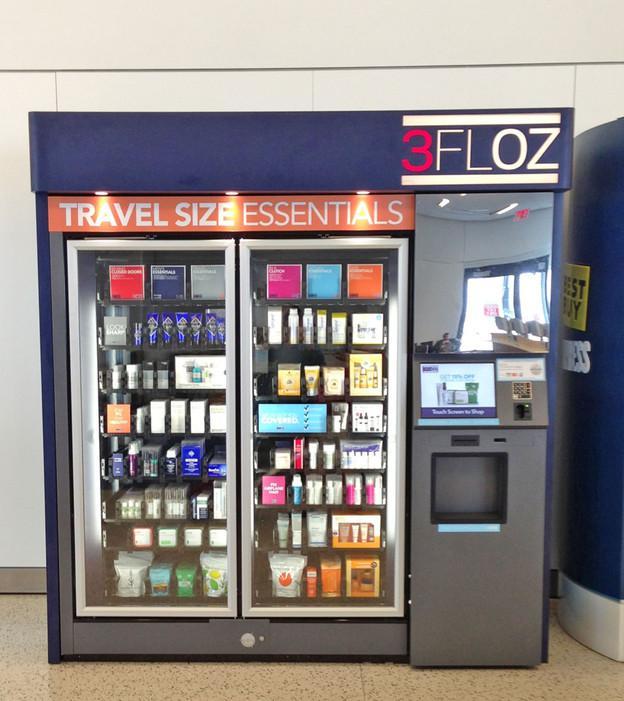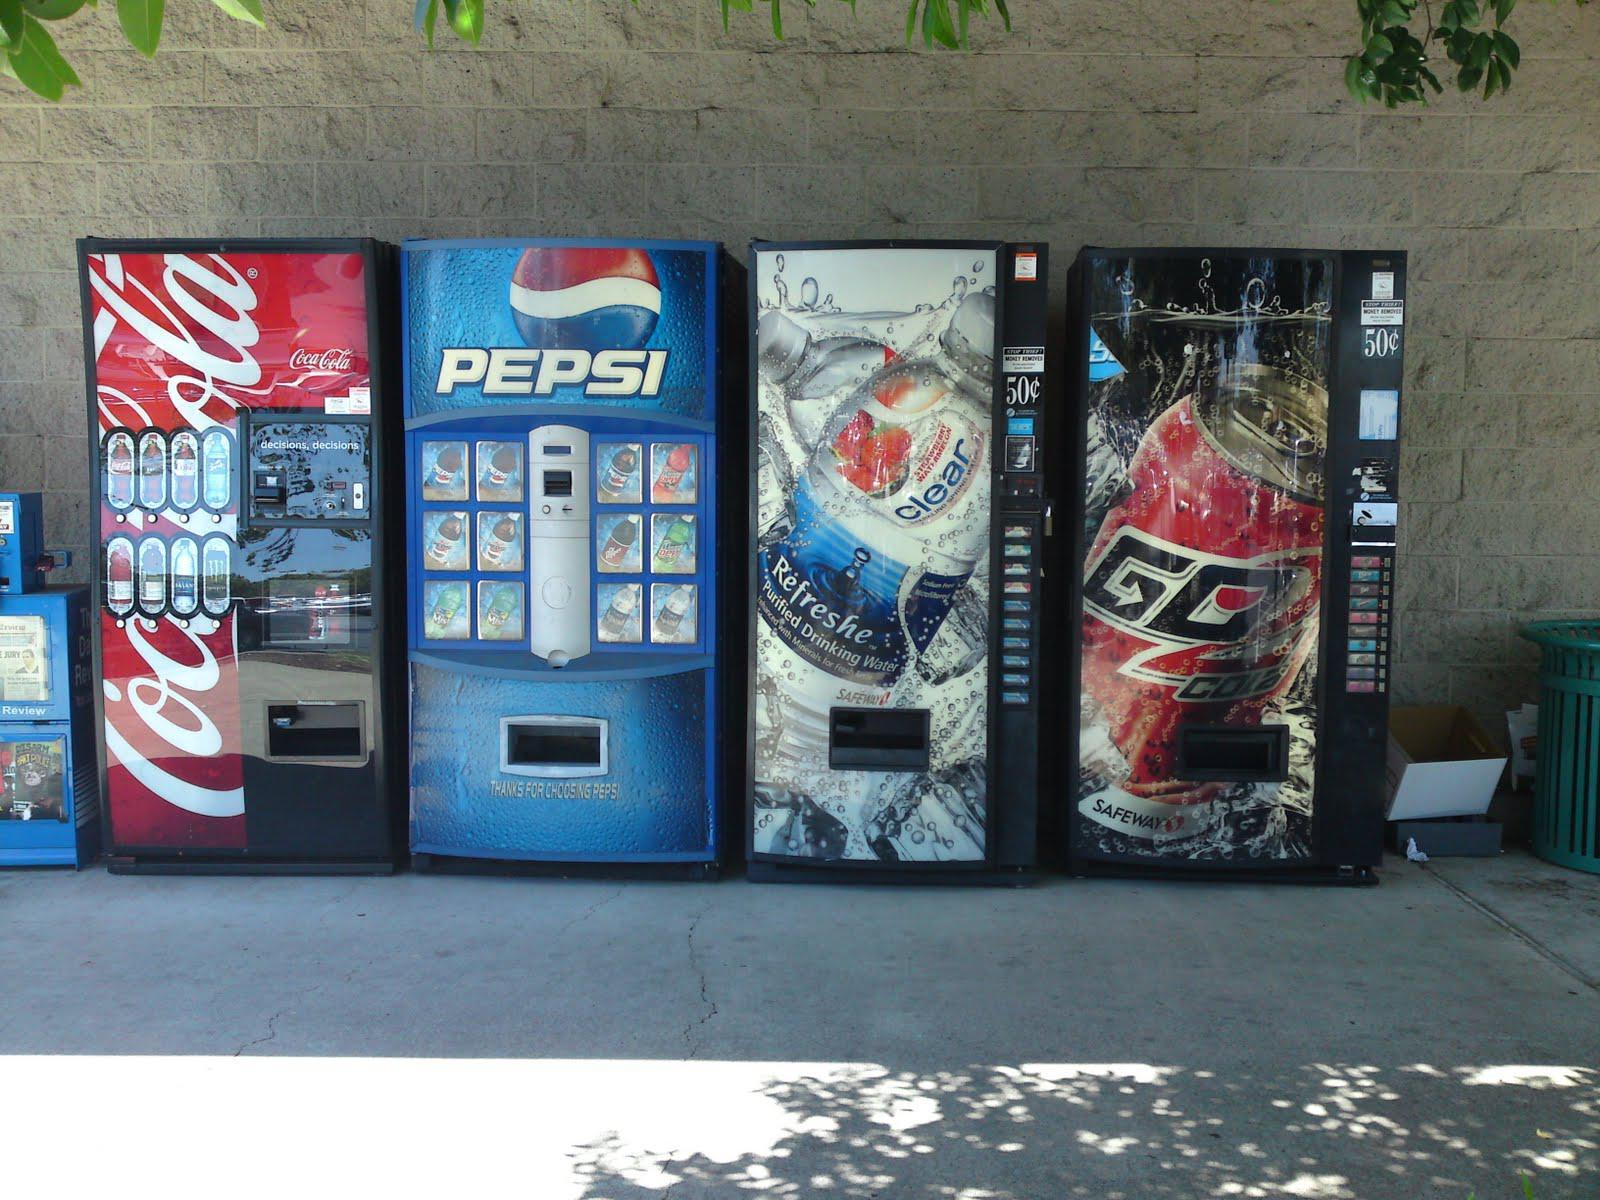The first image is the image on the left, the second image is the image on the right. Considering the images on both sides, is "Each image has two or fewer vending machines." valid? Answer yes or no. No. 